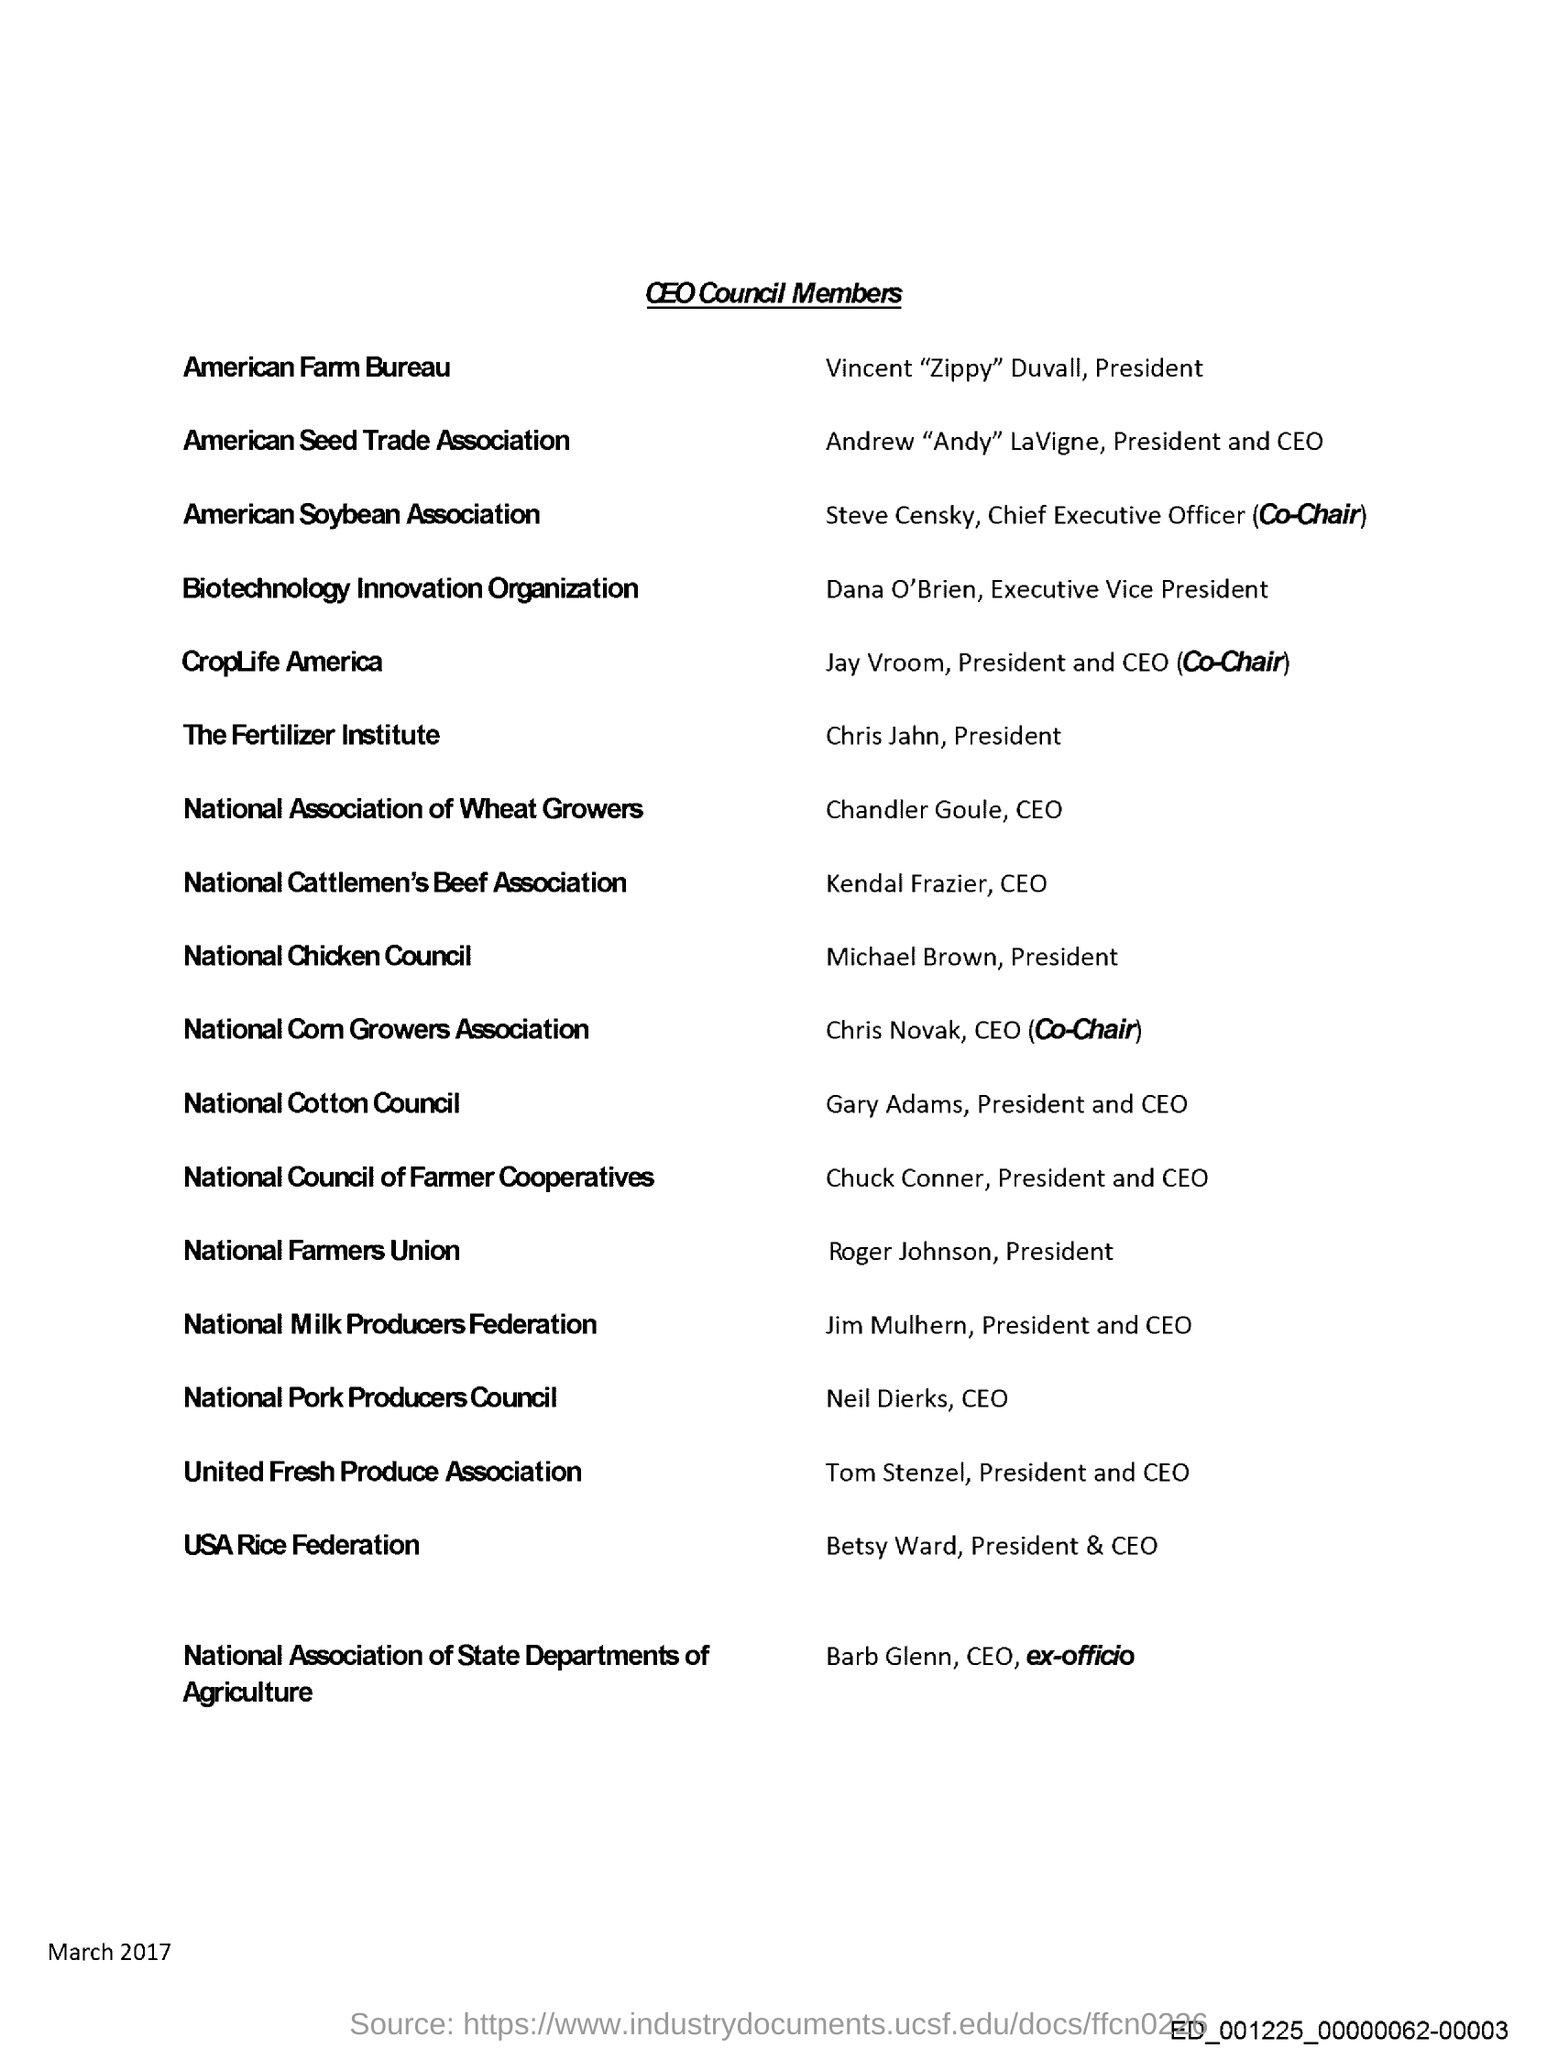Give some essential details in this illustration. This document bears the title 'CEO Council Members.' The President of The Fertilizer Institute is Chris Jahn. The date mentioned in this document is March 2017. Roger Johnson is affiliated with the National Farmers Union. 